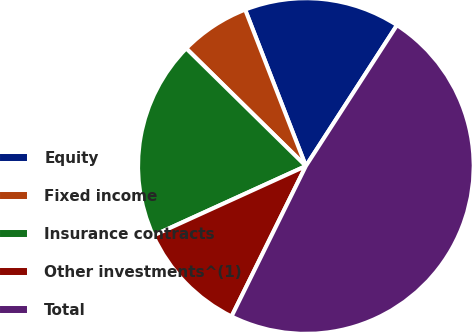<chart> <loc_0><loc_0><loc_500><loc_500><pie_chart><fcel>Equity<fcel>Fixed income<fcel>Insurance contracts<fcel>Other investments^(1)<fcel>Total<nl><fcel>15.03%<fcel>6.74%<fcel>19.17%<fcel>10.89%<fcel>48.17%<nl></chart> 